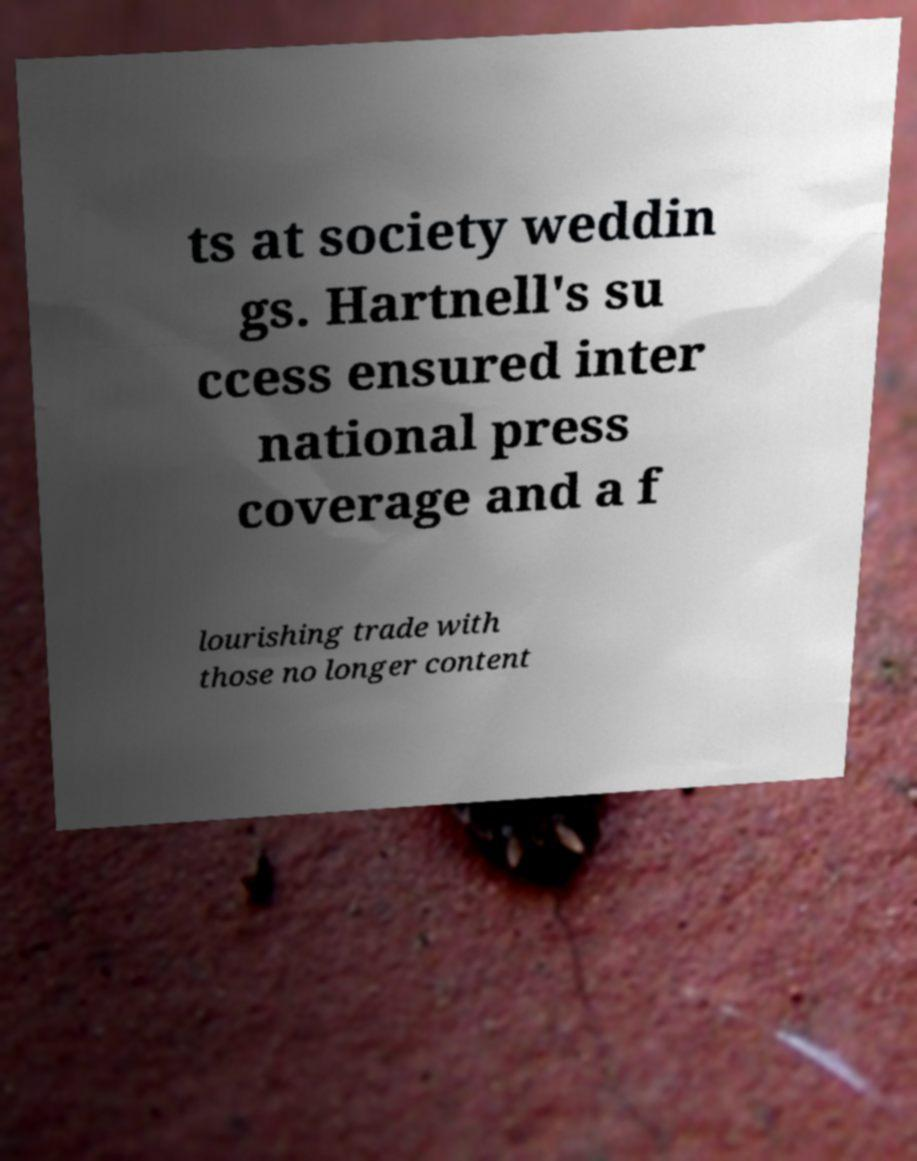Please read and relay the text visible in this image. What does it say? ts at society weddin gs. Hartnell's su ccess ensured inter national press coverage and a f lourishing trade with those no longer content 